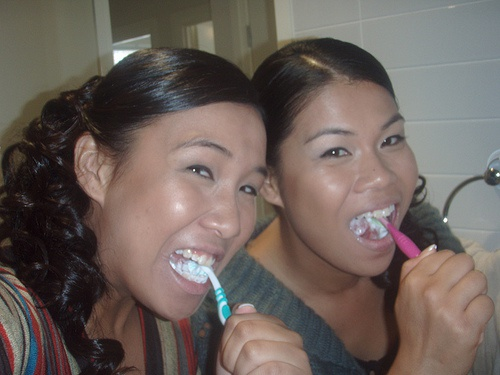Describe the objects in this image and their specific colors. I can see people in gray, black, and darkgray tones, people in gray, black, and darkgray tones, toothbrush in gray, lightblue, teal, and darkgray tones, toothbrush in gray, purple, darkgray, and maroon tones, and toothbrush in gray, darkgray, and turquoise tones in this image. 